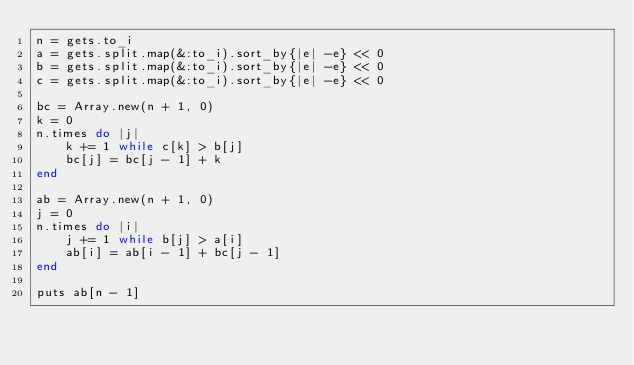Convert code to text. <code><loc_0><loc_0><loc_500><loc_500><_Ruby_>n = gets.to_i
a = gets.split.map(&:to_i).sort_by{|e| -e} << 0
b = gets.split.map(&:to_i).sort_by{|e| -e} << 0
c = gets.split.map(&:to_i).sort_by{|e| -e} << 0

bc = Array.new(n + 1, 0)
k = 0
n.times do |j|
    k += 1 while c[k] > b[j]
    bc[j] = bc[j - 1] + k
end

ab = Array.new(n + 1, 0)
j = 0
n.times do |i|
    j += 1 while b[j] > a[i]
    ab[i] = ab[i - 1] + bc[j - 1]
end

puts ab[n - 1]</code> 